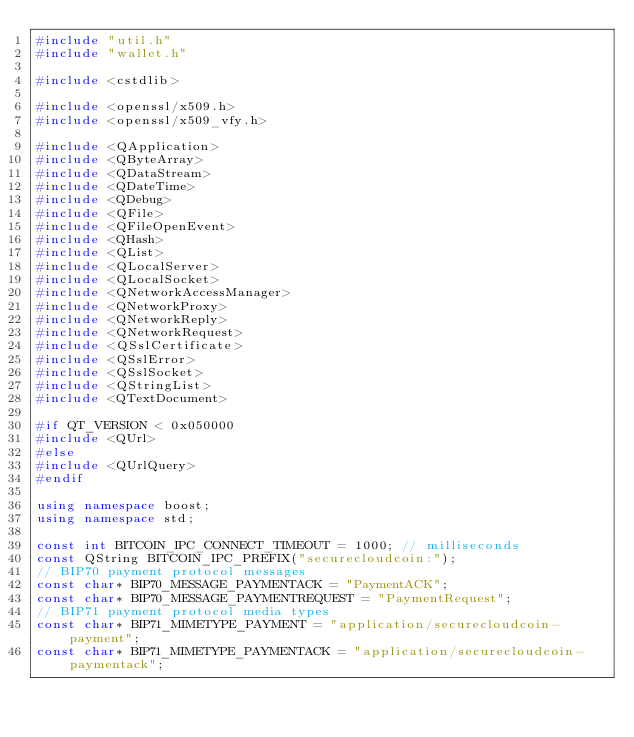Convert code to text. <code><loc_0><loc_0><loc_500><loc_500><_C++_>#include "util.h"
#include "wallet.h"

#include <cstdlib>

#include <openssl/x509.h>
#include <openssl/x509_vfy.h>

#include <QApplication>
#include <QByteArray>
#include <QDataStream>
#include <QDateTime>
#include <QDebug>
#include <QFile>
#include <QFileOpenEvent>
#include <QHash>
#include <QList>
#include <QLocalServer>
#include <QLocalSocket>
#include <QNetworkAccessManager>
#include <QNetworkProxy>
#include <QNetworkReply>
#include <QNetworkRequest>
#include <QSslCertificate>
#include <QSslError>
#include <QSslSocket>
#include <QStringList>
#include <QTextDocument>

#if QT_VERSION < 0x050000
#include <QUrl>
#else
#include <QUrlQuery>
#endif

using namespace boost;
using namespace std;

const int BITCOIN_IPC_CONNECT_TIMEOUT = 1000; // milliseconds
const QString BITCOIN_IPC_PREFIX("securecloudcoin:");
// BIP70 payment protocol messages
const char* BIP70_MESSAGE_PAYMENTACK = "PaymentACK";
const char* BIP70_MESSAGE_PAYMENTREQUEST = "PaymentRequest";
// BIP71 payment protocol media types
const char* BIP71_MIMETYPE_PAYMENT = "application/securecloudcoin-payment";
const char* BIP71_MIMETYPE_PAYMENTACK = "application/securecloudcoin-paymentack";</code> 